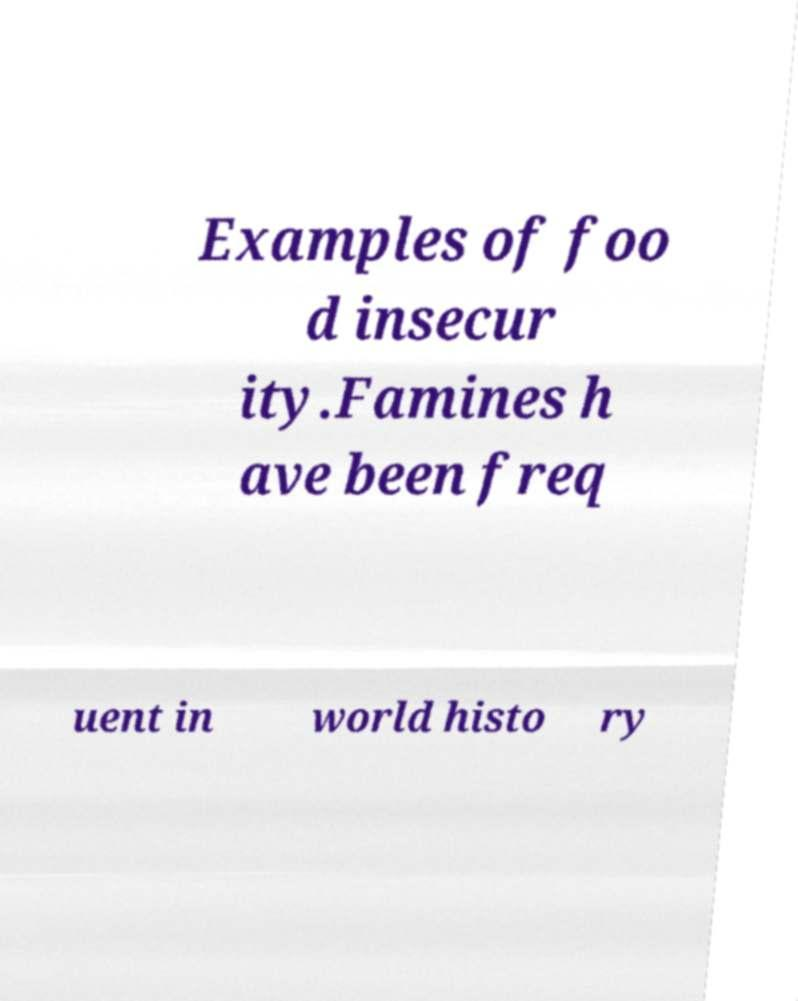Could you assist in decoding the text presented in this image and type it out clearly? Examples of foo d insecur ity.Famines h ave been freq uent in world histo ry 